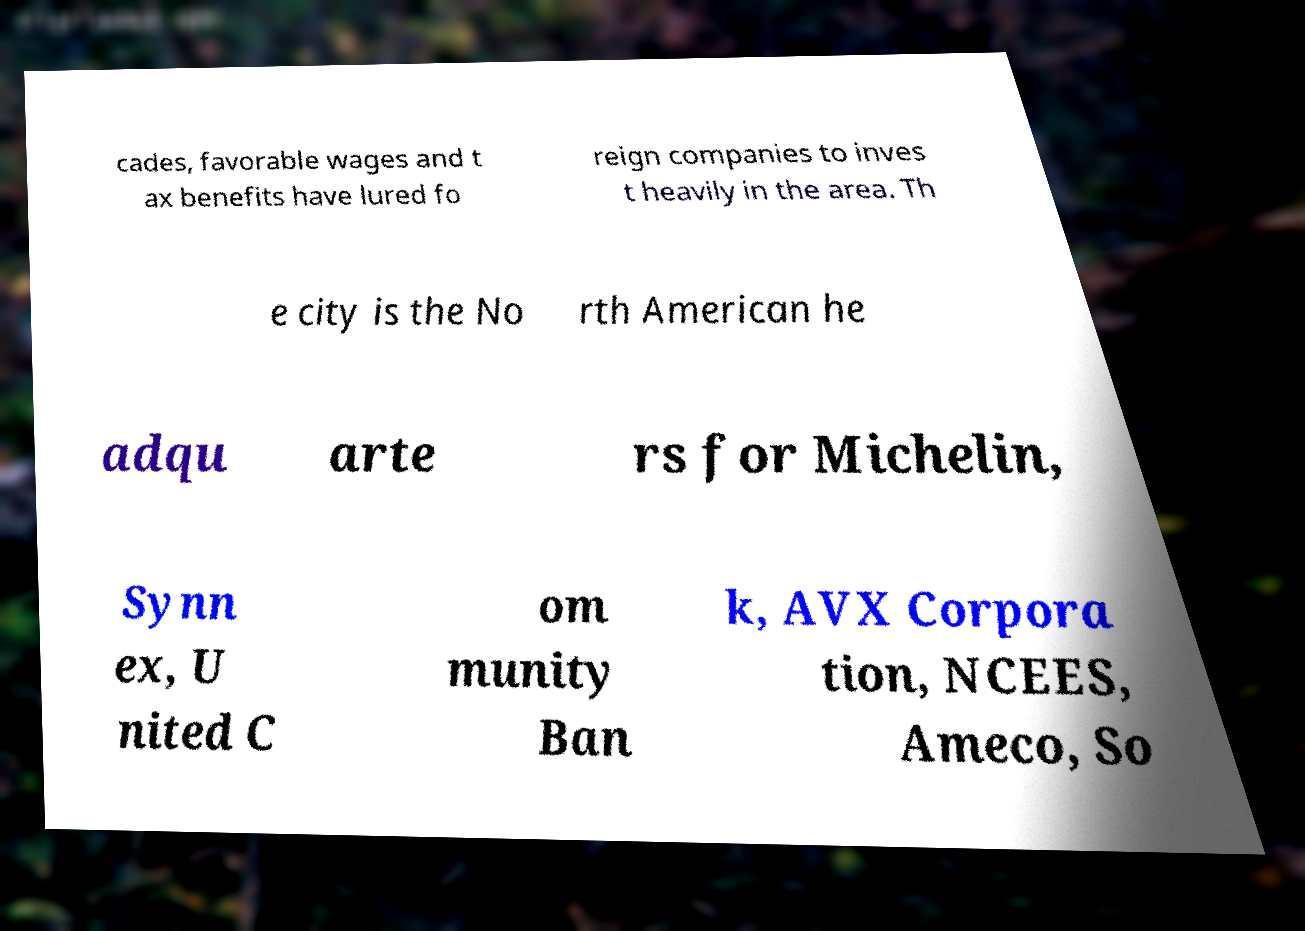Could you assist in decoding the text presented in this image and type it out clearly? cades, favorable wages and t ax benefits have lured fo reign companies to inves t heavily in the area. Th e city is the No rth American he adqu arte rs for Michelin, Synn ex, U nited C om munity Ban k, AVX Corpora tion, NCEES, Ameco, So 